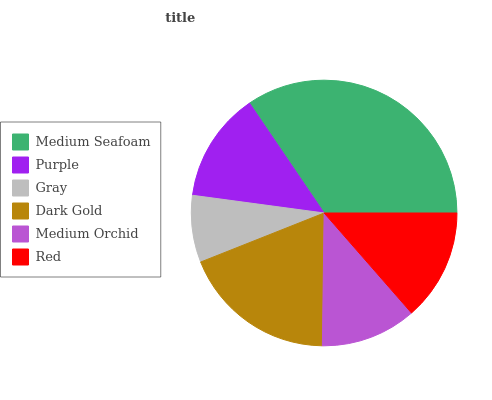Is Gray the minimum?
Answer yes or no. Yes. Is Medium Seafoam the maximum?
Answer yes or no. Yes. Is Purple the minimum?
Answer yes or no. No. Is Purple the maximum?
Answer yes or no. No. Is Medium Seafoam greater than Purple?
Answer yes or no. Yes. Is Purple less than Medium Seafoam?
Answer yes or no. Yes. Is Purple greater than Medium Seafoam?
Answer yes or no. No. Is Medium Seafoam less than Purple?
Answer yes or no. No. Is Red the high median?
Answer yes or no. Yes. Is Purple the low median?
Answer yes or no. Yes. Is Dark Gold the high median?
Answer yes or no. No. Is Red the low median?
Answer yes or no. No. 